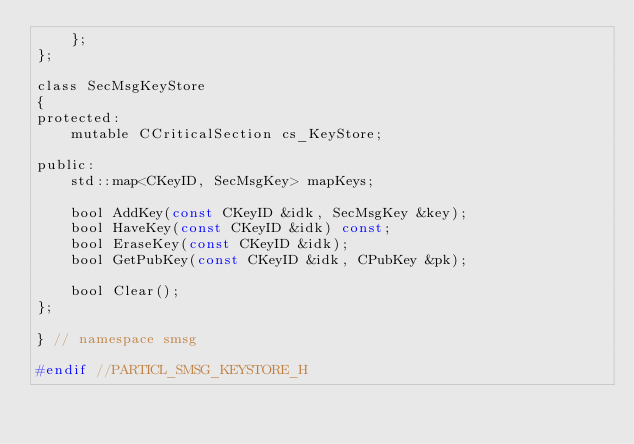Convert code to text. <code><loc_0><loc_0><loc_500><loc_500><_C_>    };
};

class SecMsgKeyStore
{
protected:
    mutable CCriticalSection cs_KeyStore;

public:
    std::map<CKeyID, SecMsgKey> mapKeys;

    bool AddKey(const CKeyID &idk, SecMsgKey &key);
    bool HaveKey(const CKeyID &idk) const;
    bool EraseKey(const CKeyID &idk);
    bool GetPubKey(const CKeyID &idk, CPubKey &pk);

    bool Clear();
};

} // namespace smsg

#endif //PARTICL_SMSG_KEYSTORE_H
</code> 